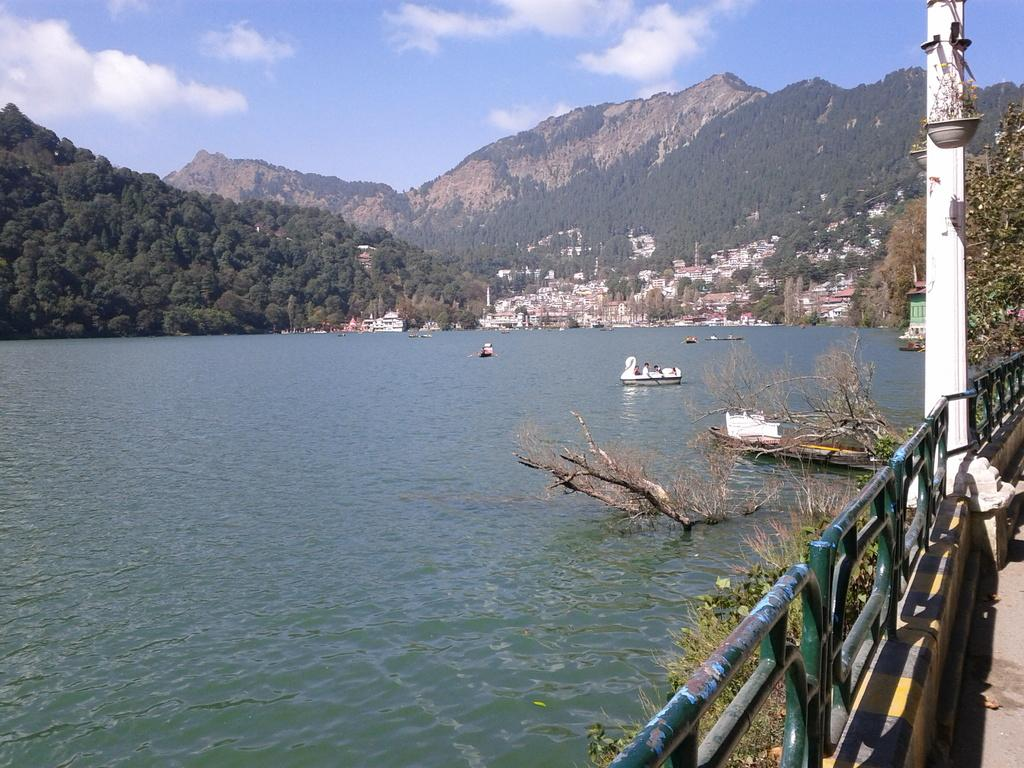What type of vehicles can be seen on the water in the image? There are boats on the water in the image. What type of structures can be seen in the image? There are buildings in the image. What type of natural elements can be seen in the image? There are trees and mountains in the image. What type of plants can be seen in the image? There are potted plants in the image. What type of man-made structures can be seen in the image? There is a fence in the image. What type of vertical structure can be seen in the image? There is a pole in the image. What part of the natural environment is visible in the image? The sky is visible in the image, and clouds are present in the sky. What is the user's thought process while digesting the image? The image does not depict a user or any digestion process, so it is not possible to determine the user's thought process while digesting the image. 